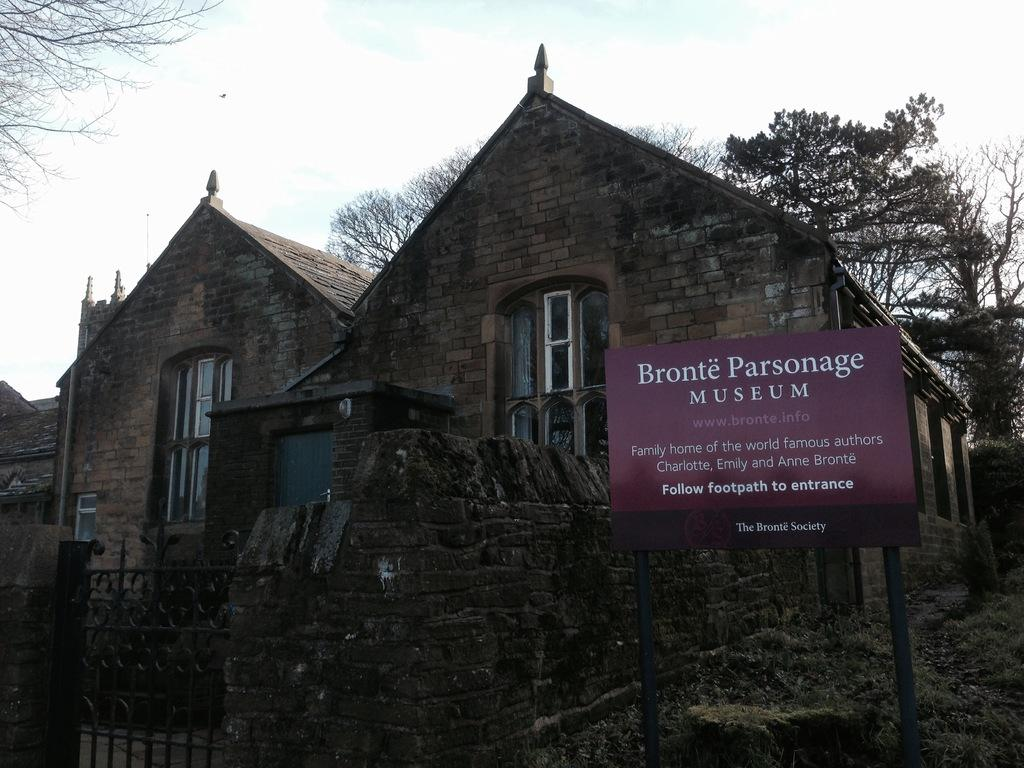What type of structures can be seen in the image? There are houses in the image. What feature is common to many of the houses in the image? There are windows in the image. What architectural element can be seen in the image? There is a gate in the image. What type of barrier is present in the image? There is a wall in the image. What object is present in the image that might be used for displaying information? There is a board in the image. What type of vegetation is visible in the image? There are trees in the image. What part of the natural environment is visible in the image? The sky is visible in the background of the image. What atmospheric conditions can be observed in the sky? There are clouds in the sky. What type of competition is taking place in the image? There is no competition present in the image. What type of stocking is hanging from the wall in the image? There is no stocking present in the image. 